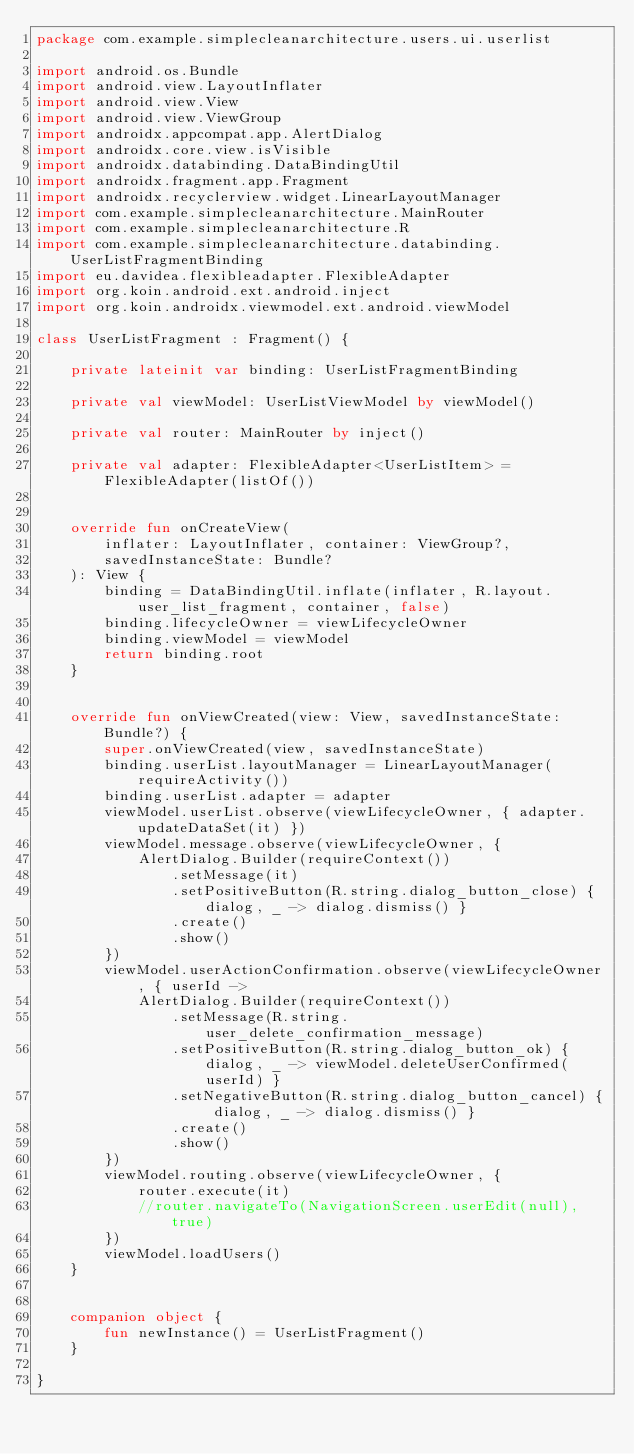<code> <loc_0><loc_0><loc_500><loc_500><_Kotlin_>package com.example.simplecleanarchitecture.users.ui.userlist

import android.os.Bundle
import android.view.LayoutInflater
import android.view.View
import android.view.ViewGroup
import androidx.appcompat.app.AlertDialog
import androidx.core.view.isVisible
import androidx.databinding.DataBindingUtil
import androidx.fragment.app.Fragment
import androidx.recyclerview.widget.LinearLayoutManager
import com.example.simplecleanarchitecture.MainRouter
import com.example.simplecleanarchitecture.R
import com.example.simplecleanarchitecture.databinding.UserListFragmentBinding
import eu.davidea.flexibleadapter.FlexibleAdapter
import org.koin.android.ext.android.inject
import org.koin.androidx.viewmodel.ext.android.viewModel

class UserListFragment : Fragment() {

    private lateinit var binding: UserListFragmentBinding

    private val viewModel: UserListViewModel by viewModel()

    private val router: MainRouter by inject()

    private val adapter: FlexibleAdapter<UserListItem> = FlexibleAdapter(listOf())


    override fun onCreateView(
        inflater: LayoutInflater, container: ViewGroup?,
        savedInstanceState: Bundle?
    ): View {
        binding = DataBindingUtil.inflate(inflater, R.layout.user_list_fragment, container, false)
        binding.lifecycleOwner = viewLifecycleOwner
        binding.viewModel = viewModel
        return binding.root
    }


    override fun onViewCreated(view: View, savedInstanceState: Bundle?) {
        super.onViewCreated(view, savedInstanceState)
        binding.userList.layoutManager = LinearLayoutManager(requireActivity())
        binding.userList.adapter = adapter
        viewModel.userList.observe(viewLifecycleOwner, { adapter.updateDataSet(it) })
        viewModel.message.observe(viewLifecycleOwner, {
            AlertDialog.Builder(requireContext())
                .setMessage(it)
                .setPositiveButton(R.string.dialog_button_close) { dialog, _ -> dialog.dismiss() }
                .create()
                .show()
        })
        viewModel.userActionConfirmation.observe(viewLifecycleOwner, { userId ->
            AlertDialog.Builder(requireContext())
                .setMessage(R.string.user_delete_confirmation_message)
                .setPositiveButton(R.string.dialog_button_ok) { dialog, _ -> viewModel.deleteUserConfirmed(userId) }
                .setNegativeButton(R.string.dialog_button_cancel) { dialog, _ -> dialog.dismiss() }
                .create()
                .show()
        })
        viewModel.routing.observe(viewLifecycleOwner, {
            router.execute(it)
            //router.navigateTo(NavigationScreen.userEdit(null), true)
        })
        viewModel.loadUsers()
    }


    companion object {
        fun newInstance() = UserListFragment()
    }

}</code> 